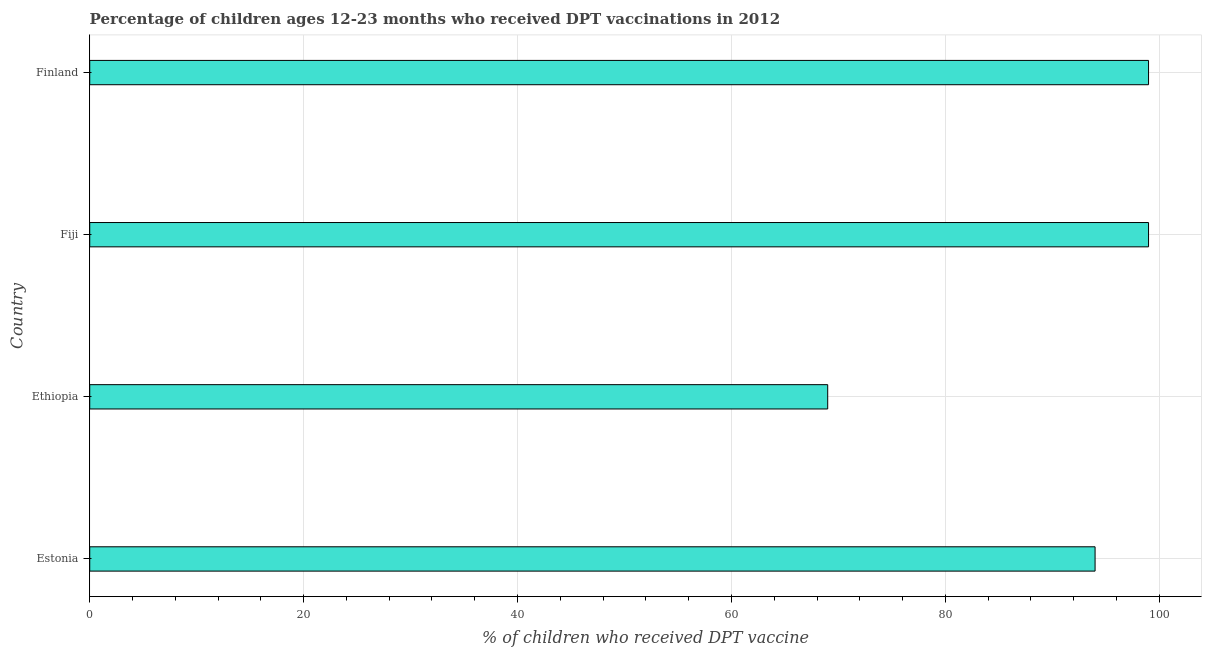What is the title of the graph?
Make the answer very short. Percentage of children ages 12-23 months who received DPT vaccinations in 2012. What is the label or title of the X-axis?
Offer a very short reply. % of children who received DPT vaccine. What is the label or title of the Y-axis?
Offer a terse response. Country. In which country was the percentage of children who received dpt vaccine maximum?
Your answer should be very brief. Fiji. In which country was the percentage of children who received dpt vaccine minimum?
Give a very brief answer. Ethiopia. What is the sum of the percentage of children who received dpt vaccine?
Your response must be concise. 361. What is the average percentage of children who received dpt vaccine per country?
Offer a very short reply. 90.25. What is the median percentage of children who received dpt vaccine?
Your answer should be compact. 96.5. What is the ratio of the percentage of children who received dpt vaccine in Ethiopia to that in Finland?
Your response must be concise. 0.7. Is the percentage of children who received dpt vaccine in Fiji less than that in Finland?
Ensure brevity in your answer.  No. Is the sum of the percentage of children who received dpt vaccine in Ethiopia and Fiji greater than the maximum percentage of children who received dpt vaccine across all countries?
Provide a short and direct response. Yes. What is the difference between the highest and the lowest percentage of children who received dpt vaccine?
Provide a short and direct response. 30. How many bars are there?
Your answer should be compact. 4. How many countries are there in the graph?
Provide a short and direct response. 4. What is the difference between two consecutive major ticks on the X-axis?
Offer a very short reply. 20. What is the % of children who received DPT vaccine of Estonia?
Provide a succinct answer. 94. What is the % of children who received DPT vaccine of Ethiopia?
Keep it short and to the point. 69. What is the difference between the % of children who received DPT vaccine in Estonia and Fiji?
Make the answer very short. -5. What is the difference between the % of children who received DPT vaccine in Estonia and Finland?
Make the answer very short. -5. What is the difference between the % of children who received DPT vaccine in Ethiopia and Fiji?
Offer a terse response. -30. What is the difference between the % of children who received DPT vaccine in Ethiopia and Finland?
Give a very brief answer. -30. What is the difference between the % of children who received DPT vaccine in Fiji and Finland?
Your answer should be very brief. 0. What is the ratio of the % of children who received DPT vaccine in Estonia to that in Ethiopia?
Keep it short and to the point. 1.36. What is the ratio of the % of children who received DPT vaccine in Estonia to that in Fiji?
Offer a terse response. 0.95. What is the ratio of the % of children who received DPT vaccine in Estonia to that in Finland?
Give a very brief answer. 0.95. What is the ratio of the % of children who received DPT vaccine in Ethiopia to that in Fiji?
Your answer should be compact. 0.7. What is the ratio of the % of children who received DPT vaccine in Ethiopia to that in Finland?
Make the answer very short. 0.7. What is the ratio of the % of children who received DPT vaccine in Fiji to that in Finland?
Your response must be concise. 1. 